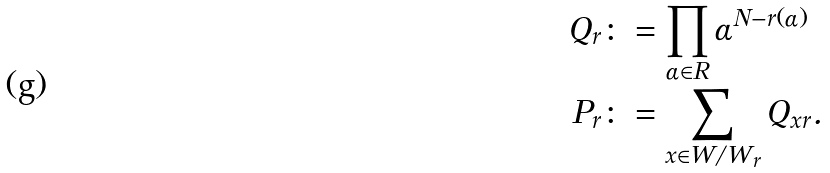Convert formula to latex. <formula><loc_0><loc_0><loc_500><loc_500>Q _ { r } & \colon = \prod _ { \alpha \in R } \alpha ^ { N - r ( \alpha ) } \\ P _ { r } & \colon = \sum _ { x \in W / W _ { r } } Q _ { x r } .</formula> 